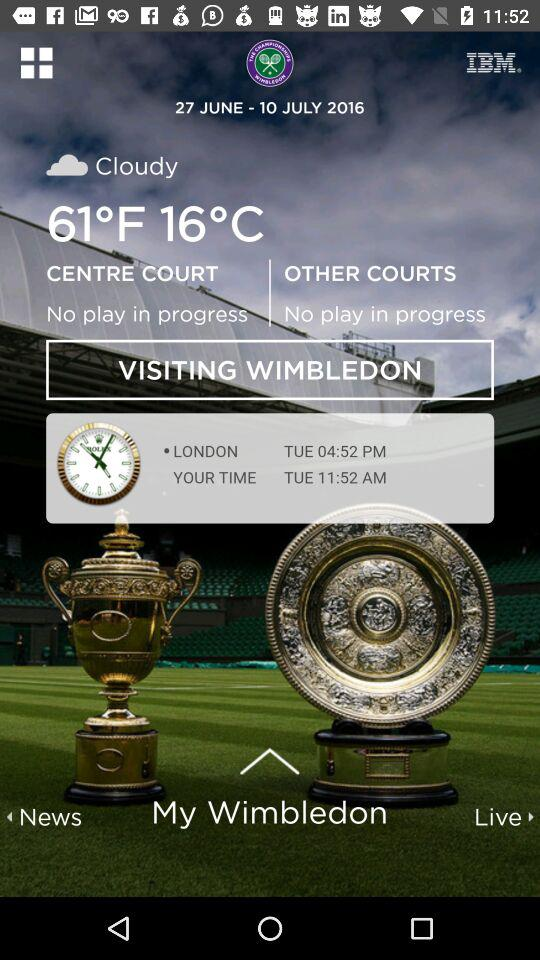What's the time in London? The time in London is 04:52 p.m. 